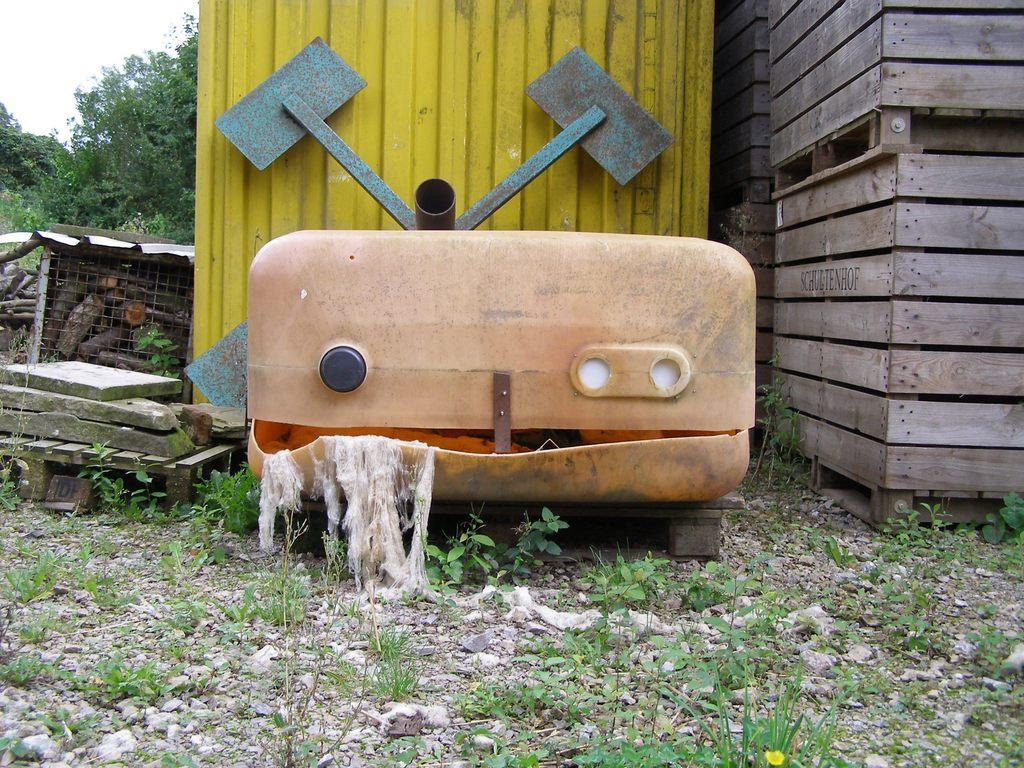What type of buildings are visible in the image? There are wooden buildings in the image. What object is located in front of the block in the image? There is a box in front of the block in the image. What can be seen beside the box in the image? There are wooden things beside the box in the image. Can you see a snake slithering around the wooden buildings in the image? There is no snake present in the image; it only features wooden buildings, a box, and wooden things beside the box. 